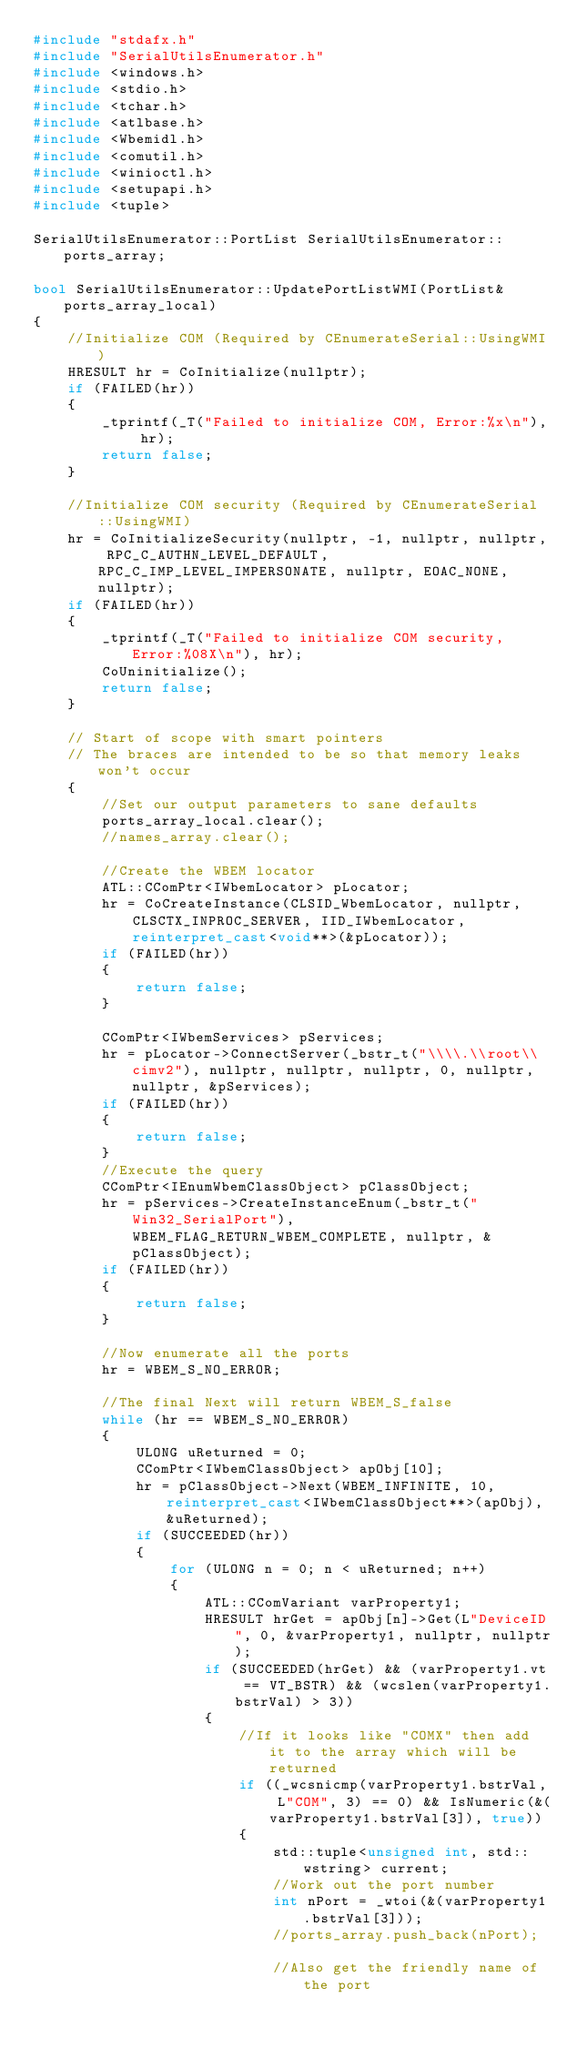Convert code to text. <code><loc_0><loc_0><loc_500><loc_500><_C++_>#include "stdafx.h"
#include "SerialUtilsEnumerator.h"
#include <windows.h>
#include <stdio.h>
#include <tchar.h>
#include <atlbase.h>
#include <Wbemidl.h>
#include <comutil.h>
#include <winioctl.h>
#include <setupapi.h>
#include <tuple>

SerialUtilsEnumerator::PortList SerialUtilsEnumerator::ports_array;

bool SerialUtilsEnumerator::UpdatePortListWMI(PortList& ports_array_local)
{
	//Initialize COM (Required by CEnumerateSerial::UsingWMI)
	HRESULT hr = CoInitialize(nullptr);
	if (FAILED(hr))
	{
		_tprintf(_T("Failed to initialize COM, Error:%x\n"), hr);
		return false;
	}

	//Initialize COM security (Required by CEnumerateSerial::UsingWMI)
	hr = CoInitializeSecurity(nullptr, -1, nullptr, nullptr, RPC_C_AUTHN_LEVEL_DEFAULT, RPC_C_IMP_LEVEL_IMPERSONATE, nullptr, EOAC_NONE, nullptr);
	if (FAILED(hr))
	{
		_tprintf(_T("Failed to initialize COM security, Error:%08X\n"), hr);
		CoUninitialize();
		return false;
	}

	// Start of scope with smart pointers
	// The braces are intended to be so that memory leaks won't occur
	{
		//Set our output parameters to sane defaults
		ports_array_local.clear();
		//names_array.clear();

		//Create the WBEM locator
		ATL::CComPtr<IWbemLocator> pLocator;
		hr = CoCreateInstance(CLSID_WbemLocator, nullptr, CLSCTX_INPROC_SERVER, IID_IWbemLocator, reinterpret_cast<void**>(&pLocator));
		if (FAILED(hr))
		{
			return false;
		}

		CComPtr<IWbemServices> pServices;
		hr = pLocator->ConnectServer(_bstr_t("\\\\.\\root\\cimv2"), nullptr, nullptr, nullptr, 0, nullptr, nullptr, &pServices);
		if (FAILED(hr))
		{
			return false;
		}
		//Execute the query
		CComPtr<IEnumWbemClassObject> pClassObject;
		hr = pServices->CreateInstanceEnum(_bstr_t("Win32_SerialPort"), WBEM_FLAG_RETURN_WBEM_COMPLETE, nullptr, &pClassObject);
		if (FAILED(hr))
		{
			return false;
		}

		//Now enumerate all the ports
		hr = WBEM_S_NO_ERROR;

		//The final Next will return WBEM_S_false
		while (hr == WBEM_S_NO_ERROR)
		{
			ULONG uReturned = 0;
			CComPtr<IWbemClassObject> apObj[10];
			hr = pClassObject->Next(WBEM_INFINITE, 10, reinterpret_cast<IWbemClassObject**>(apObj), &uReturned);
			if (SUCCEEDED(hr))
			{
				for (ULONG n = 0; n < uReturned; n++)
				{
					ATL::CComVariant varProperty1;
					HRESULT hrGet = apObj[n]->Get(L"DeviceID", 0, &varProperty1, nullptr, nullptr);
					if (SUCCEEDED(hrGet) && (varProperty1.vt == VT_BSTR) && (wcslen(varProperty1.bstrVal) > 3))
					{
						//If it looks like "COMX" then add it to the array which will be returned
						if ((_wcsnicmp(varProperty1.bstrVal, L"COM", 3) == 0) && IsNumeric(&(varProperty1.bstrVal[3]), true))
						{
							std::tuple<unsigned int, std::wstring> current;
							//Work out the port number
							int nPort = _wtoi(&(varProperty1.bstrVal[3]));
							//ports_array.push_back(nPort);

							//Also get the friendly name of the port</code> 